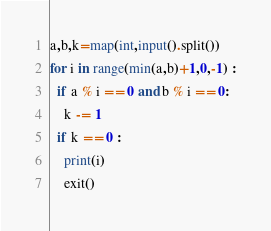<code> <loc_0><loc_0><loc_500><loc_500><_Python_>a,b,k=map(int,input().split())
for i in range(min(a,b)+1,0,-1) :
  if a % i == 0 and b % i == 0:
    k -= 1
  if k == 0 :
    print(i)
    exit()</code> 